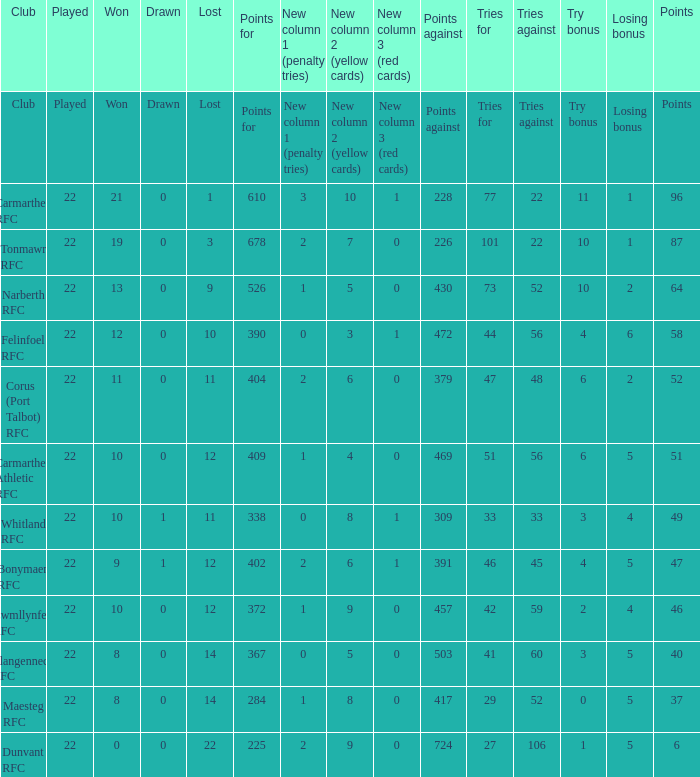Name the try bonus of points against at 430 10.0. 